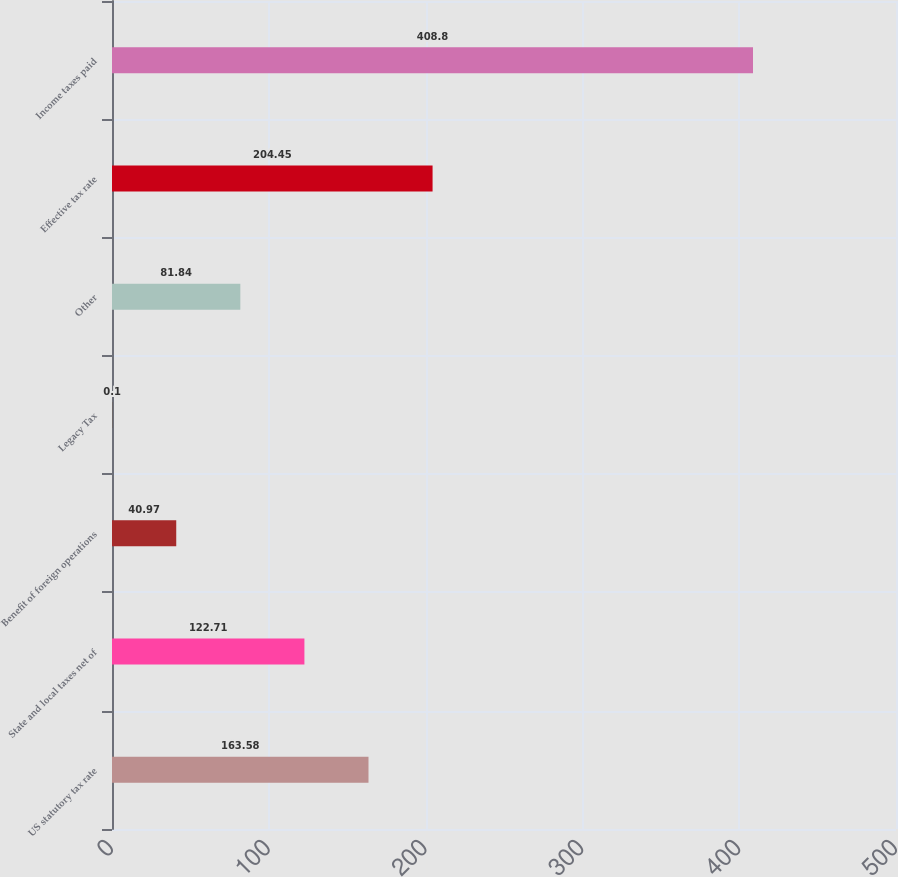Convert chart. <chart><loc_0><loc_0><loc_500><loc_500><bar_chart><fcel>US statutory tax rate<fcel>State and local taxes net of<fcel>Benefit of foreign operations<fcel>Legacy Tax<fcel>Other<fcel>Effective tax rate<fcel>Income taxes paid<nl><fcel>163.58<fcel>122.71<fcel>40.97<fcel>0.1<fcel>81.84<fcel>204.45<fcel>408.8<nl></chart> 